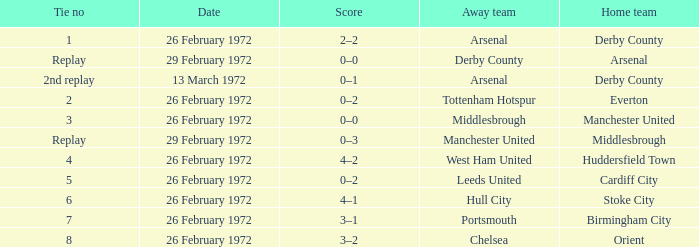Which Tie is from everton? 2.0. 